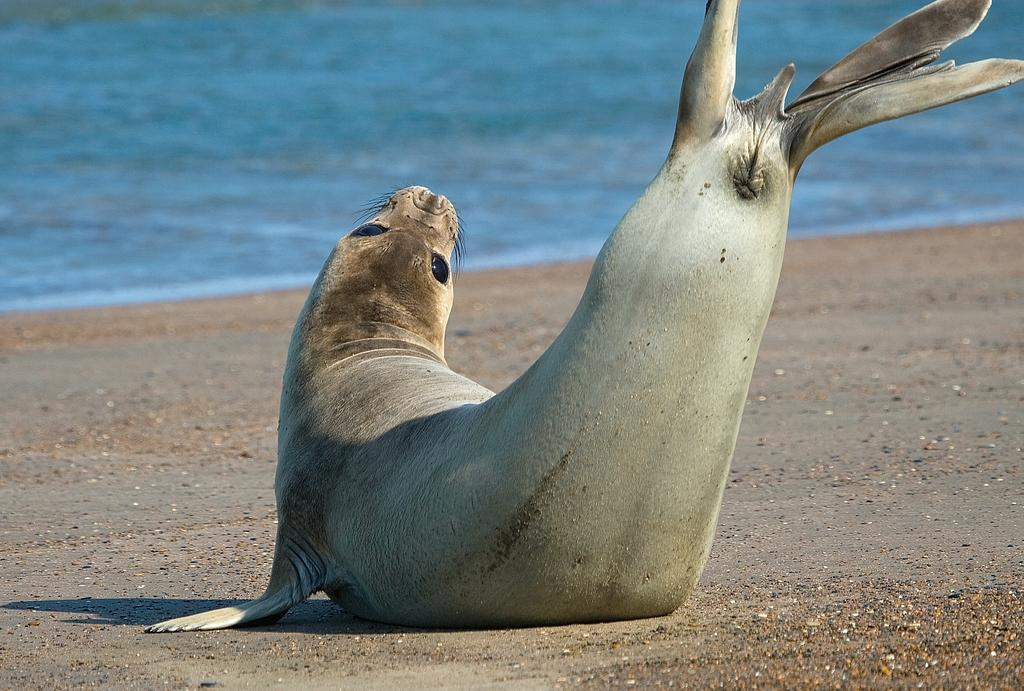What animal is present in the image? There is a seal in the image. Where is the seal located? The seal is on the sand. What can be seen in the background of the image? There is water visible in the background of the image. What type of advertisement is the seal promoting in the image? There is no advertisement present in the image; it simply features a seal on the sand with water in the background. 